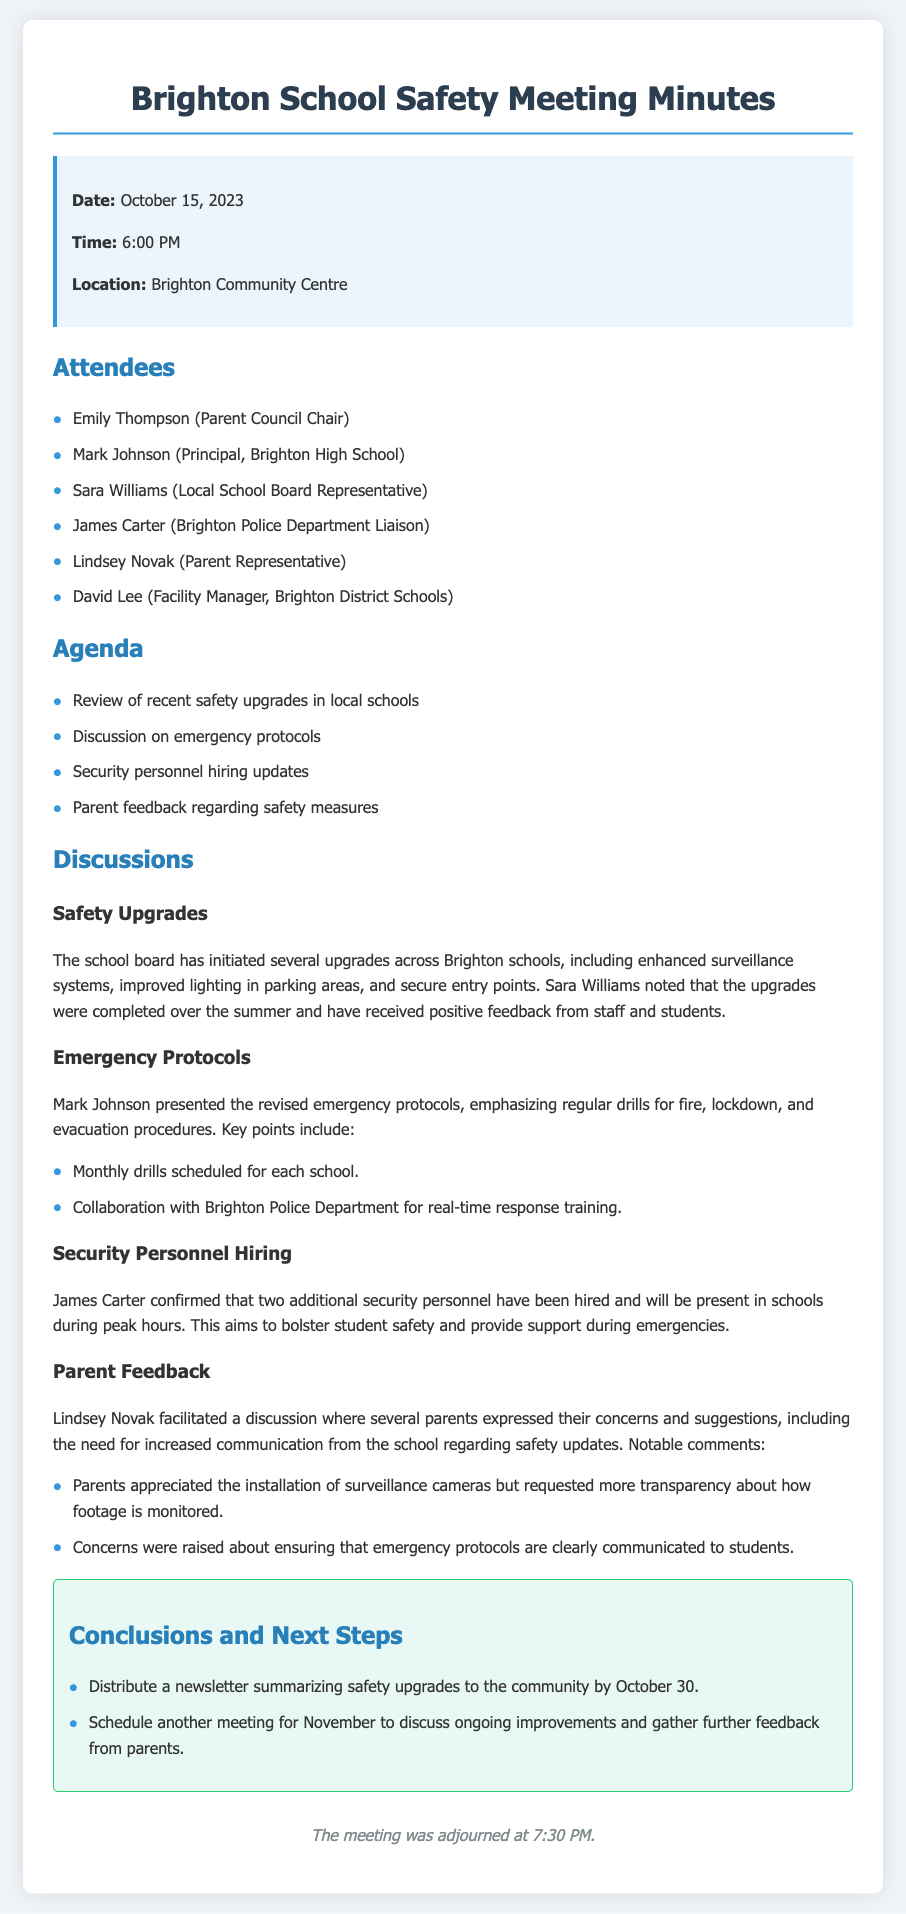what date was the meeting held? The date of the meeting is stated in the document's information box.
Answer: October 15, 2023 who confirmed the hiring of two additional security personnel? The document identifies James Carter as the one who confirmed this hiring during the discussions section.
Answer: James Carter what are the two types of drills mentioned for emergency protocols? The document lists the types of drills during the emergency protocols discussion.
Answer: fire, lockdown how many security personnel are now employed at the schools? The document specifies that two additional security personnel have been hired.
Answer: two what is the planned date for the community newsletter distribution? The deadline for distributing the newsletter is mentioned in the conclusions section.
Answer: October 30 who facilitated the discussion on parent feedback? The document names Lindsey Novak as the person who facilitated this discussion.
Answer: Lindsey Novak how long did the meeting last? The meeting start and adjournment times are mentioned, allowing for calculation of the duration.
Answer: 1 hour 30 minutes what are the planned future meeting topics focused on? The document describes the purpose of the next meeting in the conclusions section.
Answer: ongoing improvements and parent feedback 